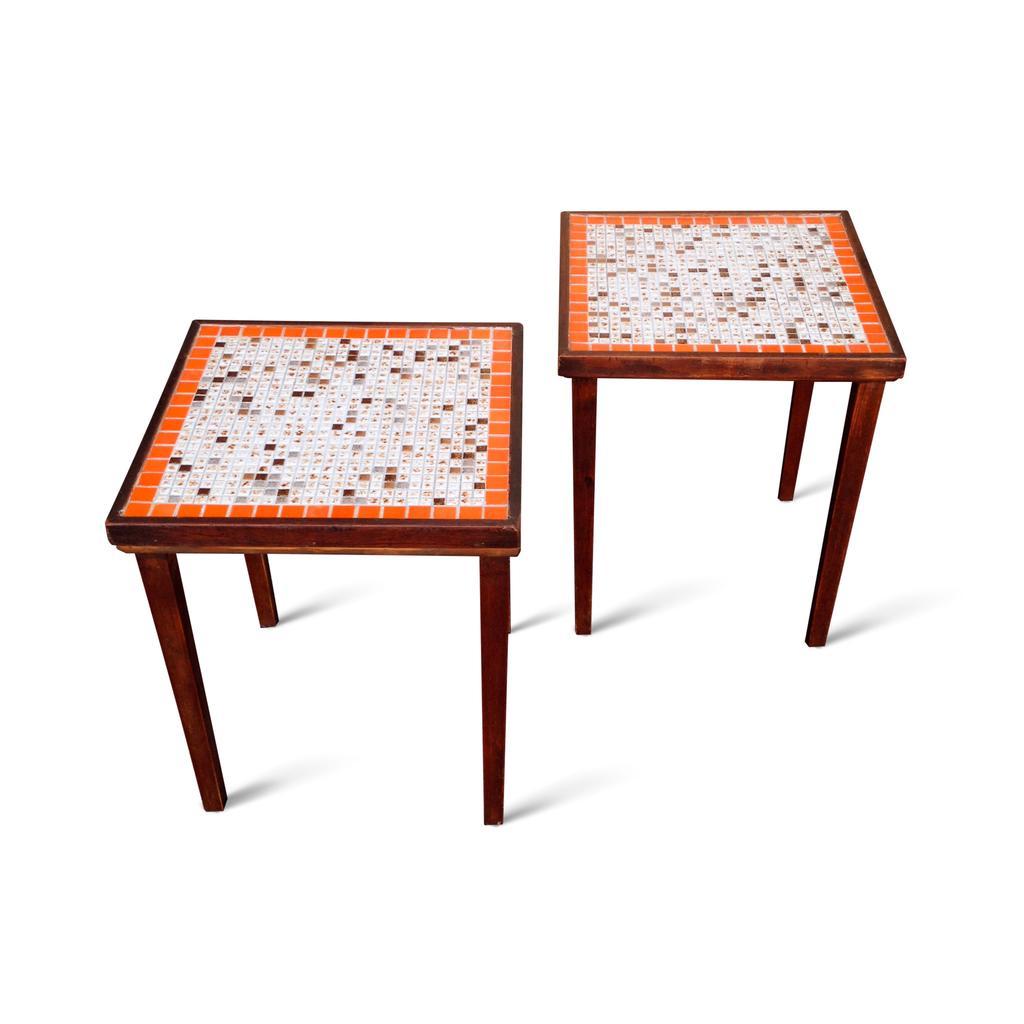Describe this image in one or two sentences. In this image there are two tables, the background of the image is white in color. 